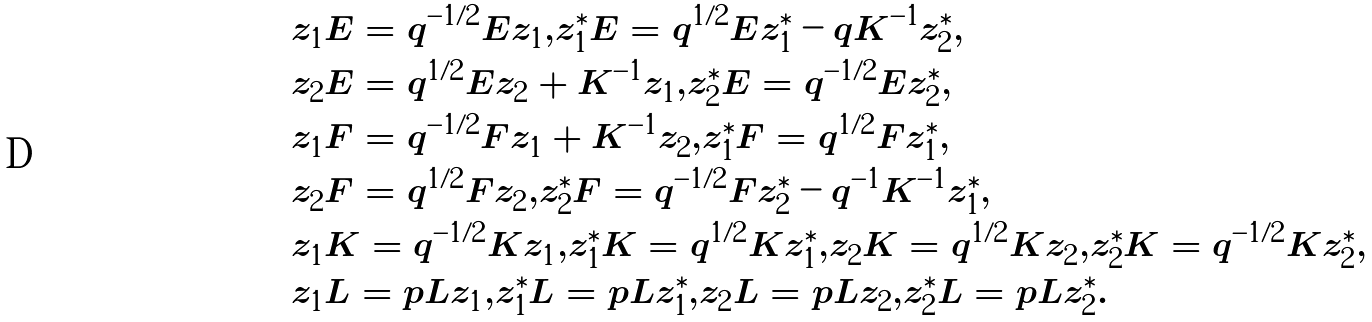<formula> <loc_0><loc_0><loc_500><loc_500>& z _ { 1 } E = q ^ { - 1 / 2 } E z _ { 1 } , z _ { 1 } ^ { \ast } E = q ^ { 1 / 2 } E z _ { 1 } ^ { \ast } - q K ^ { - 1 } z ^ { \ast } _ { 2 } , \\ & z _ { 2 } E = q ^ { 1 / 2 } E z _ { 2 } + K ^ { - 1 } z _ { 1 } , z _ { 2 } ^ { \ast } E = q ^ { - 1 / 2 } E z _ { 2 } ^ { \ast } , \\ & z _ { 1 } F = q ^ { - 1 / 2 } F z _ { 1 } + K ^ { - 1 } z _ { 2 } , z ^ { \ast } _ { 1 } F = q ^ { 1 / 2 } F z ^ { \ast } _ { 1 } , \\ & z _ { 2 } F = q ^ { 1 / 2 } F z _ { 2 } , z ^ { \ast } _ { 2 } F = q ^ { - 1 / 2 } F z ^ { \ast } _ { 2 } - q ^ { - 1 } K ^ { - 1 } z ^ { \ast } _ { 1 } , \\ & z _ { 1 } K = q ^ { - 1 / 2 } K z _ { 1 } , z ^ { \ast } _ { 1 } K = q ^ { 1 / 2 } K z ^ { \ast } _ { 1 } , z _ { 2 } K = q ^ { 1 / 2 } K z _ { 2 } , z ^ { \ast } _ { 2 } K = q ^ { - 1 / 2 } K z ^ { \ast } _ { 2 } , \\ & z _ { 1 } L = p L z _ { 1 } , z ^ { \ast } _ { 1 } L = p L z ^ { \ast } _ { 1 } , z _ { 2 } L = p L z _ { 2 } , z ^ { \ast } _ { 2 } L = p L z ^ { \ast } _ { 2 } .</formula> 